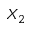<formula> <loc_0><loc_0><loc_500><loc_500>X _ { 2 }</formula> 